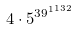<formula> <loc_0><loc_0><loc_500><loc_500>4 \cdot 5 ^ { { 3 9 ^ { 1 } } ^ { 1 3 2 } }</formula> 